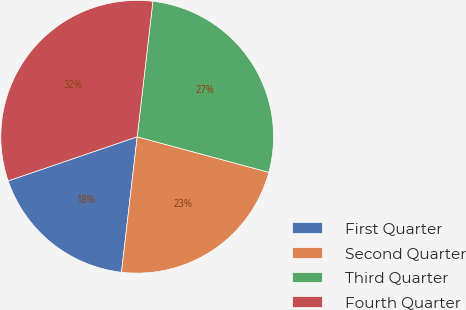<chart> <loc_0><loc_0><loc_500><loc_500><pie_chart><fcel>First Quarter<fcel>Second Quarter<fcel>Third Quarter<fcel>Fourth Quarter<nl><fcel>17.92%<fcel>22.64%<fcel>27.36%<fcel>32.08%<nl></chart> 